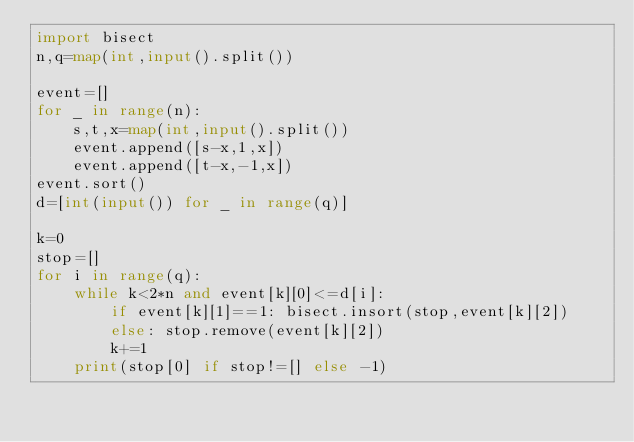Convert code to text. <code><loc_0><loc_0><loc_500><loc_500><_Python_>import bisect
n,q=map(int,input().split())

event=[]
for _ in range(n):
    s,t,x=map(int,input().split())
    event.append([s-x,1,x])
    event.append([t-x,-1,x])
event.sort()
d=[int(input()) for _ in range(q)]

k=0
stop=[]
for i in range(q):
    while k<2*n and event[k][0]<=d[i]:
        if event[k][1]==1: bisect.insort(stop,event[k][2])
        else: stop.remove(event[k][2])
        k+=1
    print(stop[0] if stop!=[] else -1)</code> 